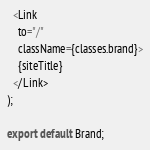<code> <loc_0><loc_0><loc_500><loc_500><_TypeScript_>  <Link
    to="/"
    className={classes.brand}>
    {siteTitle}
  </Link>
);

export default Brand;
</code> 